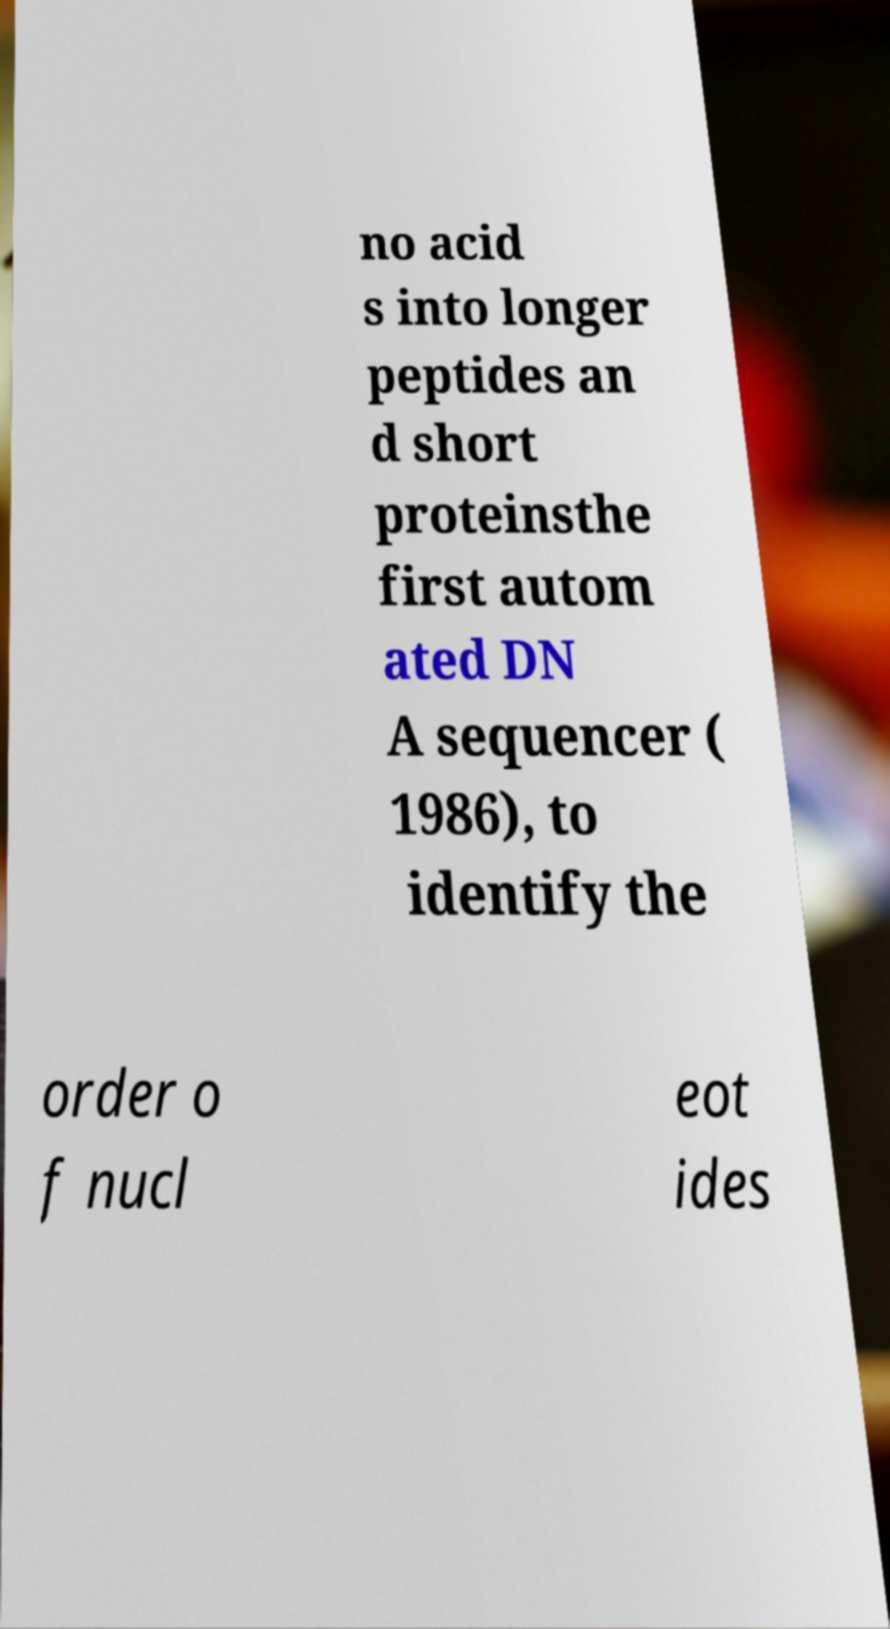There's text embedded in this image that I need extracted. Can you transcribe it verbatim? no acid s into longer peptides an d short proteinsthe first autom ated DN A sequencer ( 1986), to identify the order o f nucl eot ides 